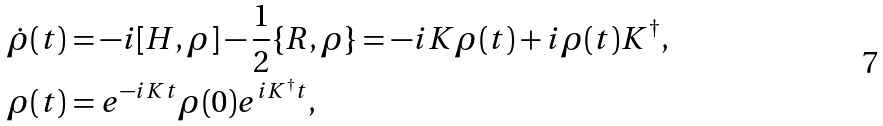Convert formula to latex. <formula><loc_0><loc_0><loc_500><loc_500>\dot { \rho } ( t ) & = - i [ H , \rho ] - \frac { 1 } { 2 } \{ R , \rho \} = - i K \rho ( t ) + i \rho ( t ) K ^ { \dagger } , \\ \rho ( t ) & = e ^ { - i K t } \rho ( 0 ) e ^ { i K ^ { \dagger } t } ,</formula> 